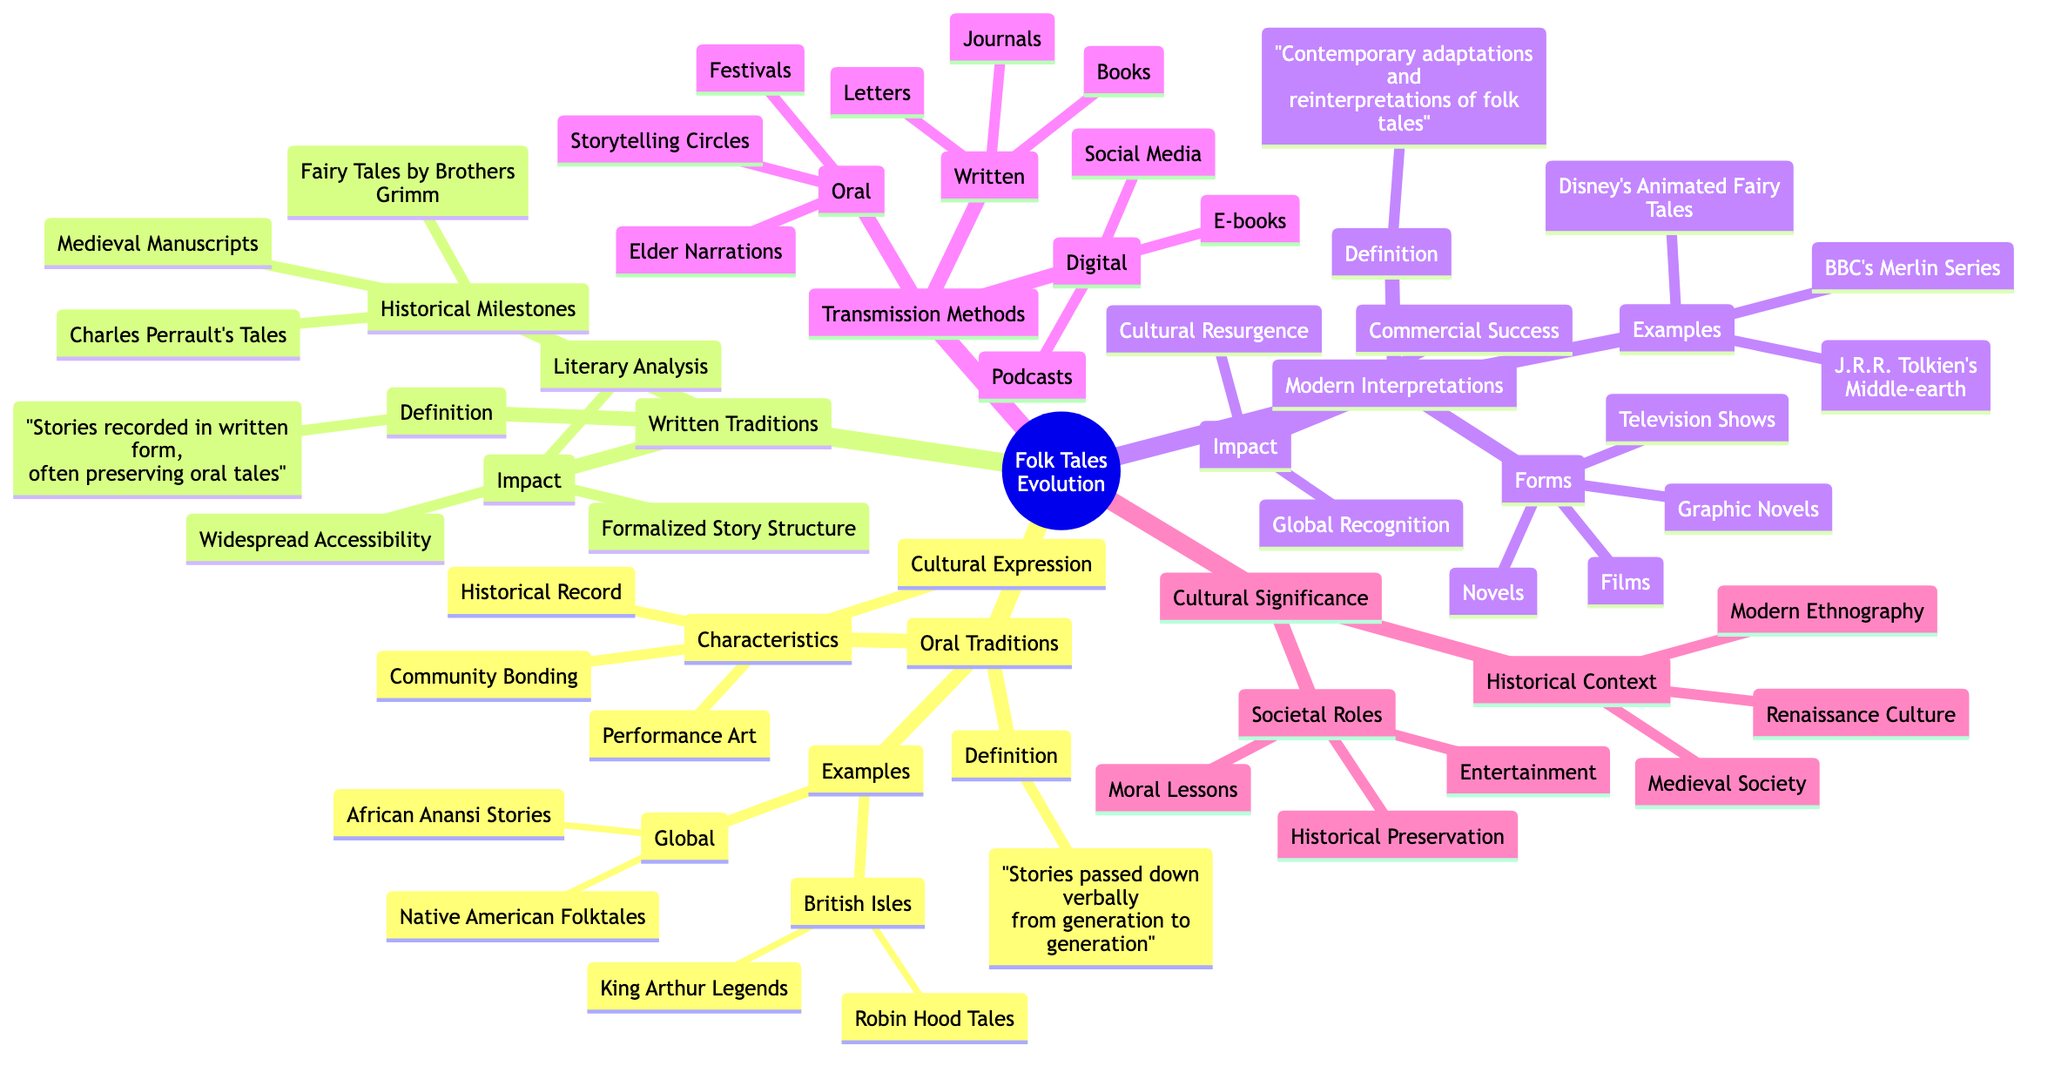What is the definition of Oral Traditions? The diagram states that Oral Traditions are "Stories passed down verbally from generation to generation." This is directly pulled from the definition node under Oral Traditions.
Answer: Stories passed down verbally from generation to generation How many characteristics are listed under Oral Traditions? The diagram shows four distinct characteristics under the Oral Traditions node: Community Bonding, Performance Art, Cultural Expression, and Historical Record. By counting these, we find there are four.
Answer: Four What is one example of Written Traditions? Looking at the examples provided under Written Traditions, one specific example is "Fairy Tales by Brothers Grimm." This is found in the examples section of the Written Traditions node.
Answer: Fairy Tales by Brothers Grimm What forms do Modern Interpretations take? The diagram lists four forms under the Modern Interpretations node: Novels, Films, Graphic Novels, and Television Shows. These can be identified clearly as the forms of modern adaptations.
Answer: Novels, Films, Graphic Novels, Television Shows What transmission method is associated with storytelling circles? Within the Transmission Methods section under Oral, storytelling circles are explicitly listed as a way stories were transmitted verbally. This connection can be confirmed by locating the specific method under the Oral node.
Answer: Storytelling Circles What impact does Written Traditions have? The impact described for Written Traditions includes three aspects: Formalized Story Structure, Widespread Accessibility, and Literary Analysis. The answer can be deduced by referencing the impact section of Written Traditions.
Answer: Formalized Story Structure, Widespread Accessibility, Literary Analysis How many societal roles are mentioned in the Cultural Significance node? The diagram highlights three roles under the Societal Roles of Cultural Significance: Moral Lessons, Entertainment, and Historical Preservation. By referring to the node, we find there are three societal roles discussed.
Answer: Three Which historical context is listed for Cultural Significance? The Historical Context sub-node under Cultural Significance includes Medieval Society, Renaissance Culture, and Modern Ethnography. This indicates one of the historical contexts would be Medieval Society, which is one of the examples.
Answer: Medieval Society What is a modern example of folklore adaptation? The diagram provides examples of modern interpretations, specifically mentioning "Disney’s Animated Fairy Tales." This example is one of the direct interpretations of folklore in contemporary media.
Answer: Disney’s Animated Fairy Tales 